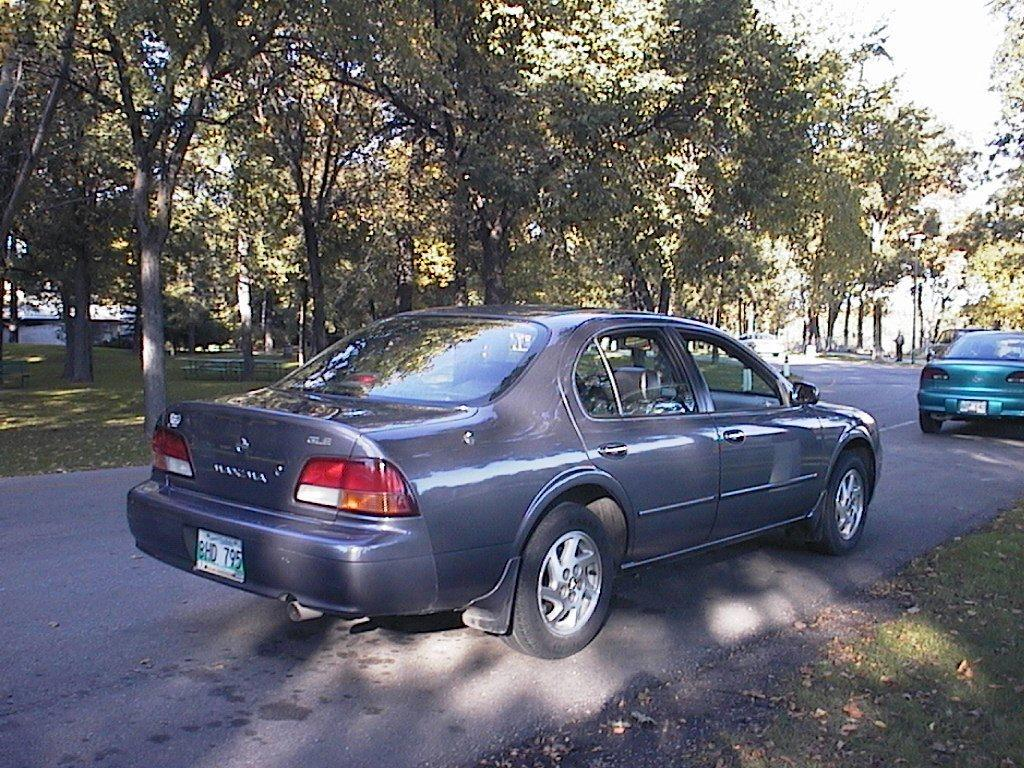What type of natural elements can be seen in the image? There are trees in the image. What part of the natural environment is visible in the image? The sky is visible in the image. What type of man-made structures are present in the image? There are vehicles on the road in the image. What type of flowers are growing near the trees in the image? There are no flowers visible in the image; only trees and vehicles on the road are present. 